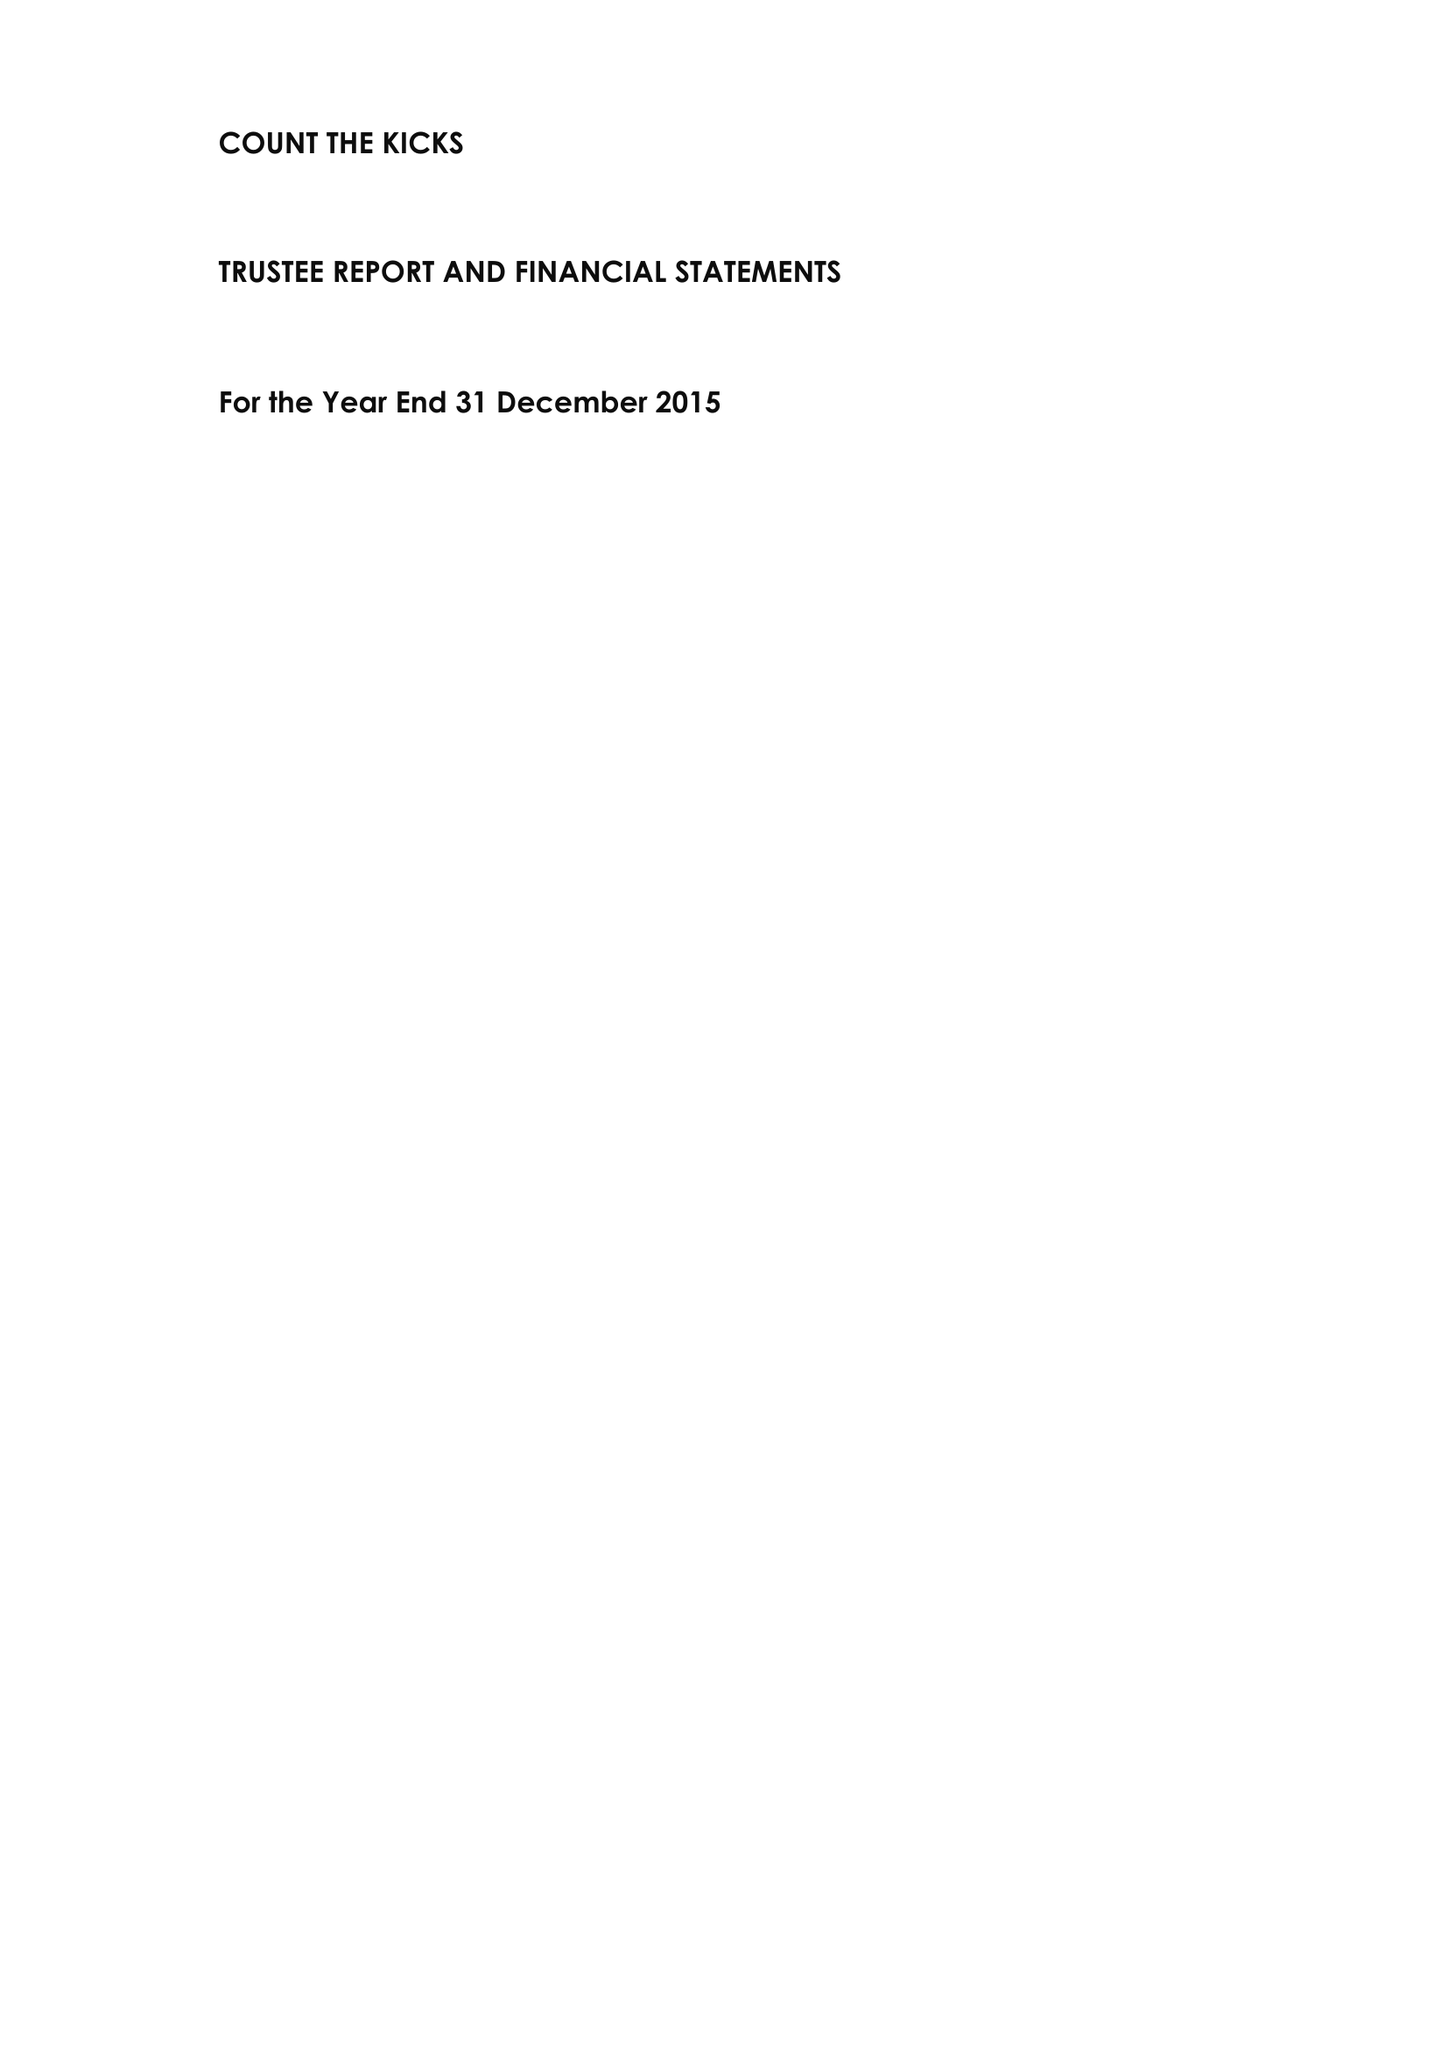What is the value for the income_annually_in_british_pounds?
Answer the question using a single word or phrase. 240164.00 